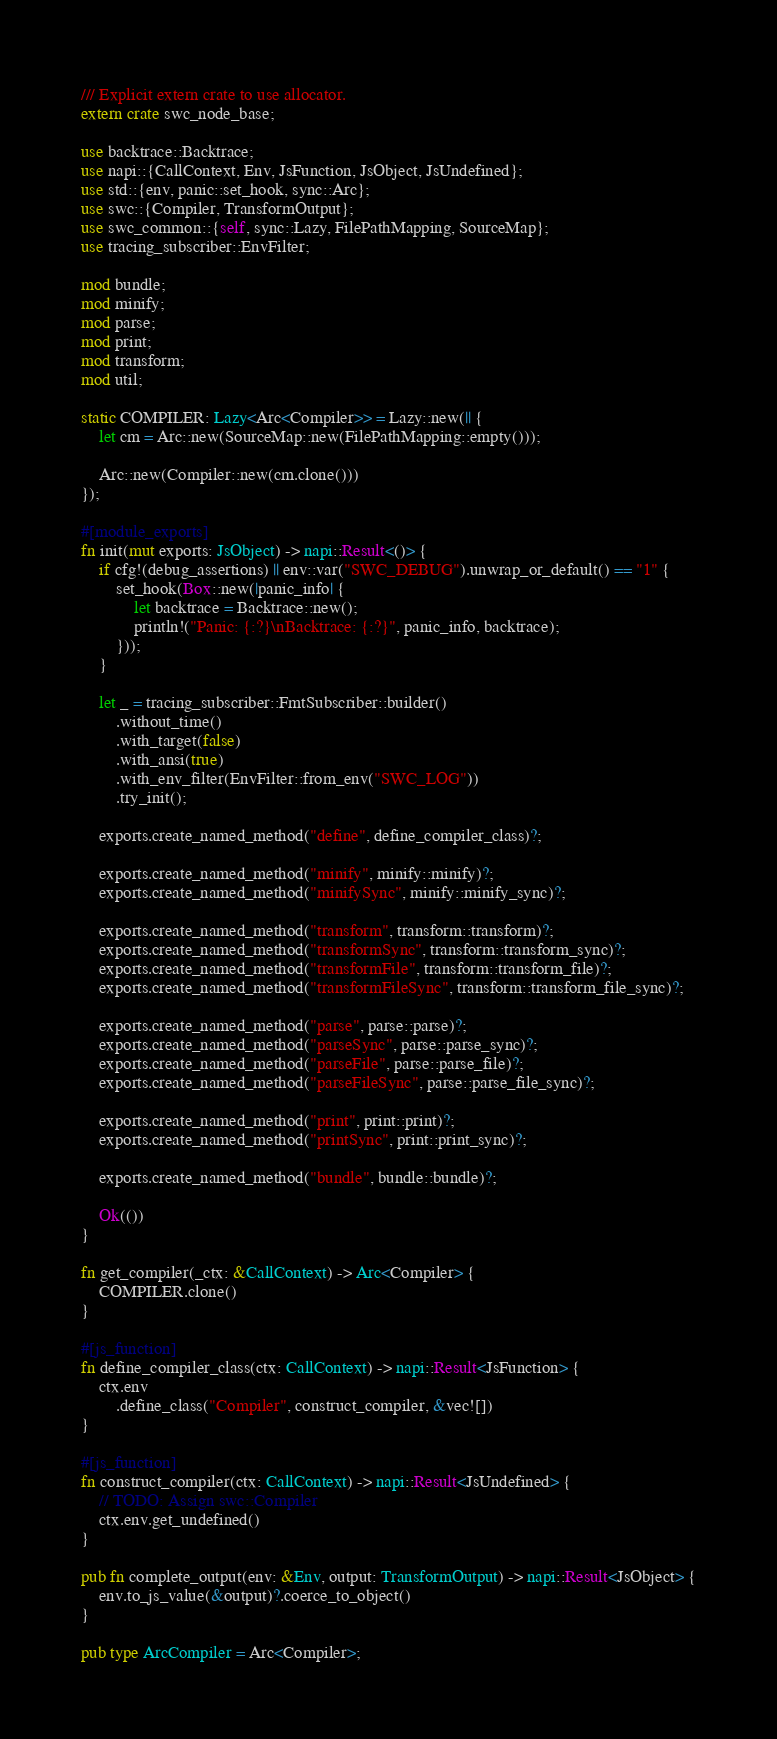Convert code to text. <code><loc_0><loc_0><loc_500><loc_500><_Rust_>/// Explicit extern crate to use allocator.
extern crate swc_node_base;

use backtrace::Backtrace;
use napi::{CallContext, Env, JsFunction, JsObject, JsUndefined};
use std::{env, panic::set_hook, sync::Arc};
use swc::{Compiler, TransformOutput};
use swc_common::{self, sync::Lazy, FilePathMapping, SourceMap};
use tracing_subscriber::EnvFilter;

mod bundle;
mod minify;
mod parse;
mod print;
mod transform;
mod util;

static COMPILER: Lazy<Arc<Compiler>> = Lazy::new(|| {
    let cm = Arc::new(SourceMap::new(FilePathMapping::empty()));

    Arc::new(Compiler::new(cm.clone()))
});

#[module_exports]
fn init(mut exports: JsObject) -> napi::Result<()> {
    if cfg!(debug_assertions) || env::var("SWC_DEBUG").unwrap_or_default() == "1" {
        set_hook(Box::new(|panic_info| {
            let backtrace = Backtrace::new();
            println!("Panic: {:?}\nBacktrace: {:?}", panic_info, backtrace);
        }));
    }

    let _ = tracing_subscriber::FmtSubscriber::builder()
        .without_time()
        .with_target(false)
        .with_ansi(true)
        .with_env_filter(EnvFilter::from_env("SWC_LOG"))
        .try_init();

    exports.create_named_method("define", define_compiler_class)?;

    exports.create_named_method("minify", minify::minify)?;
    exports.create_named_method("minifySync", minify::minify_sync)?;

    exports.create_named_method("transform", transform::transform)?;
    exports.create_named_method("transformSync", transform::transform_sync)?;
    exports.create_named_method("transformFile", transform::transform_file)?;
    exports.create_named_method("transformFileSync", transform::transform_file_sync)?;

    exports.create_named_method("parse", parse::parse)?;
    exports.create_named_method("parseSync", parse::parse_sync)?;
    exports.create_named_method("parseFile", parse::parse_file)?;
    exports.create_named_method("parseFileSync", parse::parse_file_sync)?;

    exports.create_named_method("print", print::print)?;
    exports.create_named_method("printSync", print::print_sync)?;

    exports.create_named_method("bundle", bundle::bundle)?;

    Ok(())
}

fn get_compiler(_ctx: &CallContext) -> Arc<Compiler> {
    COMPILER.clone()
}

#[js_function]
fn define_compiler_class(ctx: CallContext) -> napi::Result<JsFunction> {
    ctx.env
        .define_class("Compiler", construct_compiler, &vec![])
}

#[js_function]
fn construct_compiler(ctx: CallContext) -> napi::Result<JsUndefined> {
    // TODO: Assign swc::Compiler
    ctx.env.get_undefined()
}

pub fn complete_output(env: &Env, output: TransformOutput) -> napi::Result<JsObject> {
    env.to_js_value(&output)?.coerce_to_object()
}

pub type ArcCompiler = Arc<Compiler>;
</code> 